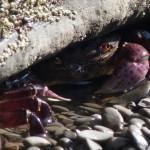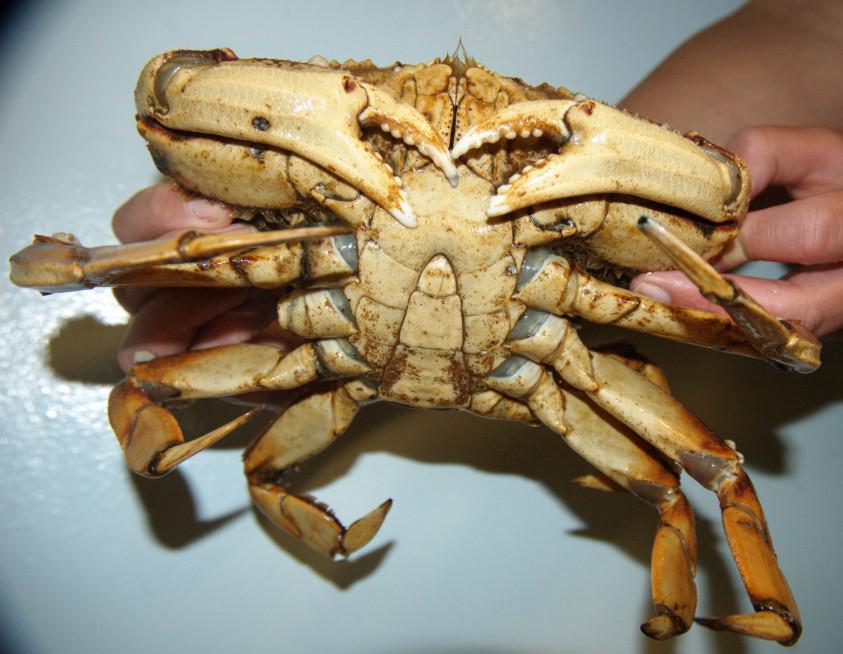The first image is the image on the left, the second image is the image on the right. Analyze the images presented: Is the assertion "One image shows the top of a reddish-orange crab, and the other image shows the bottom of at least one crab." valid? Answer yes or no. No. The first image is the image on the left, the second image is the image on the right. Examine the images to the left and right. Is the description "There are more than three crabs." accurate? Answer yes or no. No. 